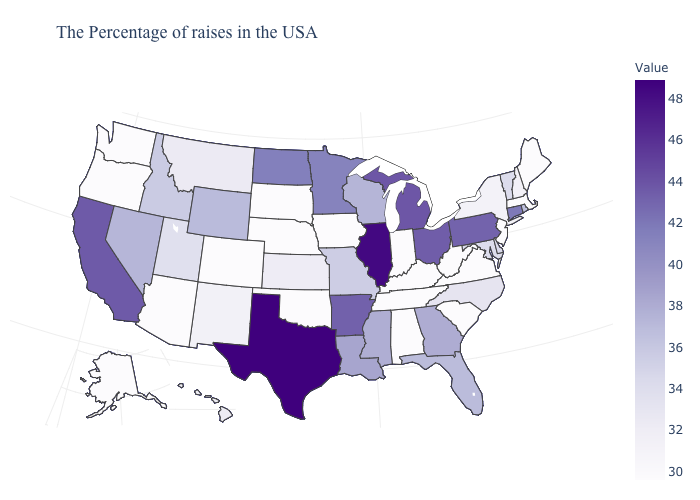Is the legend a continuous bar?
Answer briefly. Yes. Among the states that border Montana , which have the highest value?
Give a very brief answer. North Dakota. Among the states that border Virginia , does Maryland have the lowest value?
Short answer required. No. Which states have the lowest value in the USA?
Concise answer only. Maine, Massachusetts, New Jersey, Virginia, South Carolina, West Virginia, Kentucky, Indiana, Alabama, Tennessee, Iowa, Nebraska, Oklahoma, South Dakota, Colorado, Arizona, Washington, Oregon, Alaska. 